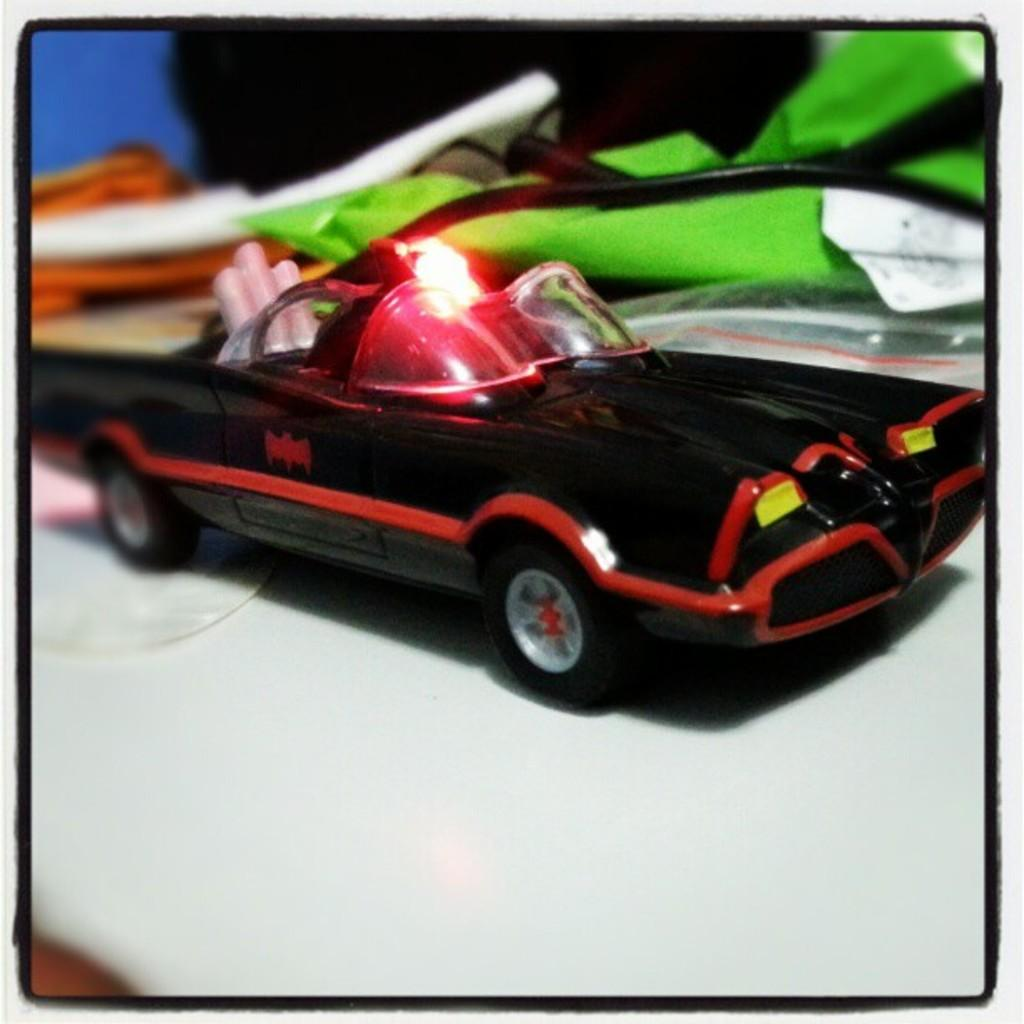What type of toy is present in the image? There is a black toy car in the image. What is the color of the surface on which the toy car is placed? The toy car is placed on a white surface. Can you describe the background of the image? There are objects visible in the background of the image. How is the left side of the image different from the rest? The left side of the image is slightly blurred. How many family members are visible in the image? There are no family members present in the image; it features a black toy car on a white surface. What level of difficulty is the zipper on the toy car set to? There is no mention of a zipper on the toy car in the image. 